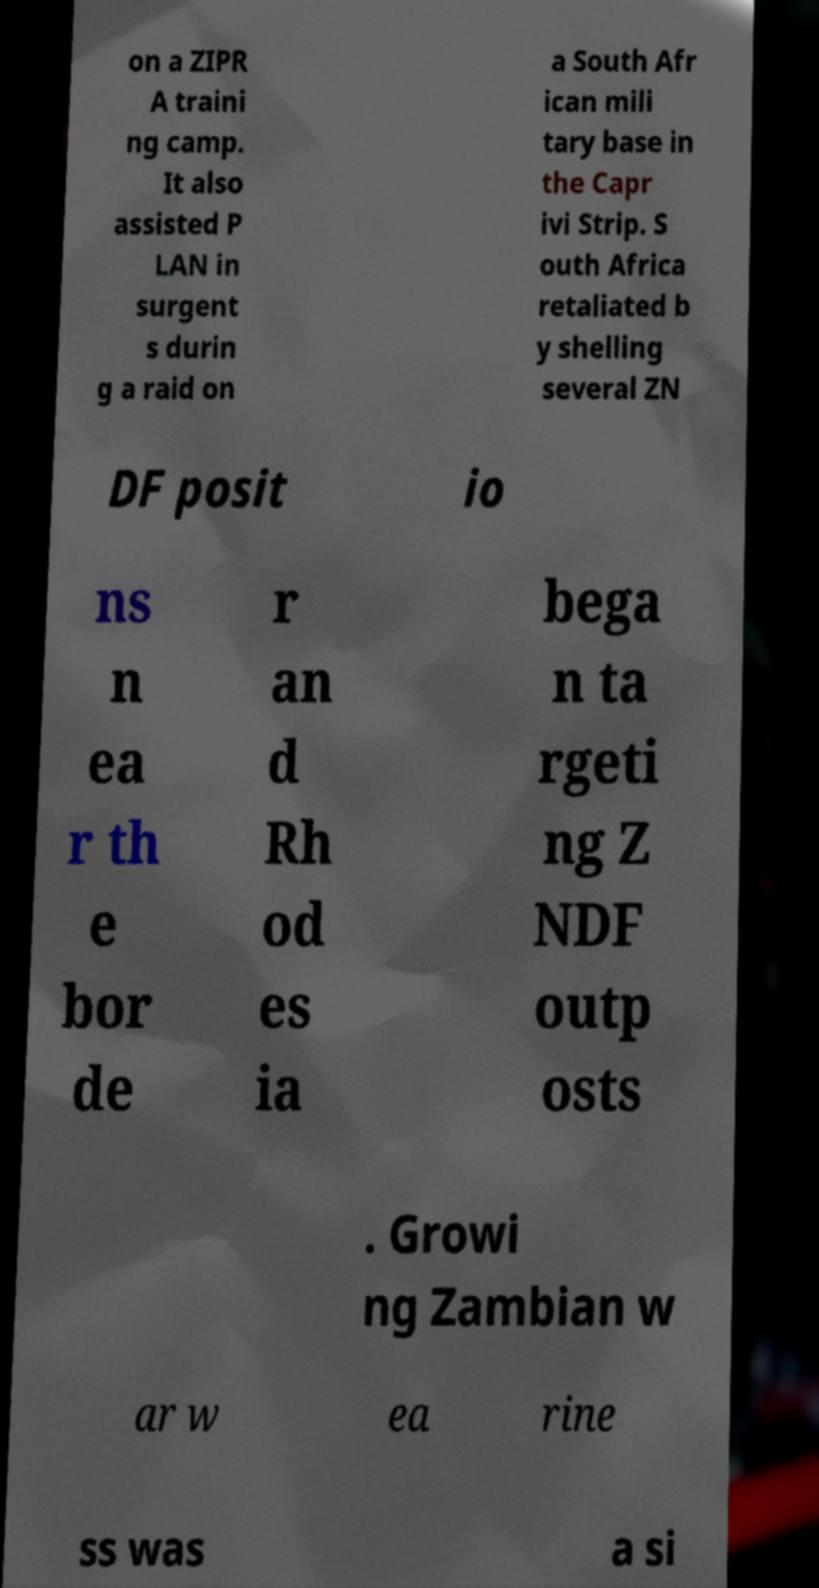Please identify and transcribe the text found in this image. on a ZIPR A traini ng camp. It also assisted P LAN in surgent s durin g a raid on a South Afr ican mili tary base in the Capr ivi Strip. S outh Africa retaliated b y shelling several ZN DF posit io ns n ea r th e bor de r an d Rh od es ia bega n ta rgeti ng Z NDF outp osts . Growi ng Zambian w ar w ea rine ss was a si 